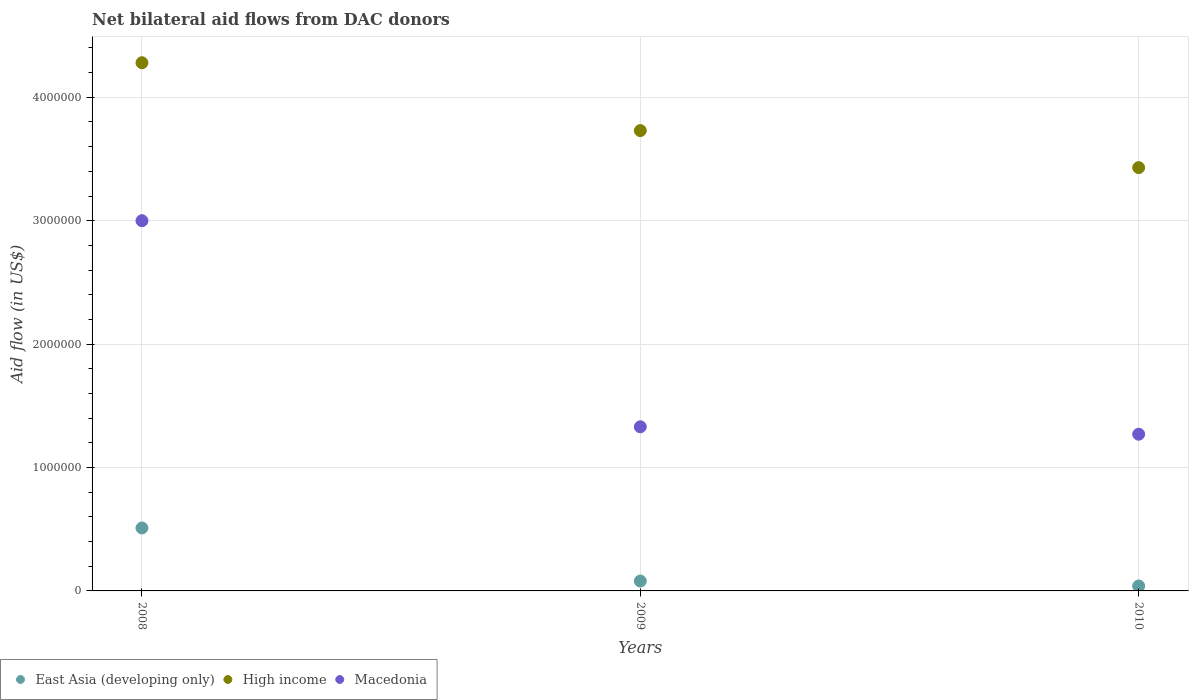How many different coloured dotlines are there?
Keep it short and to the point. 3. What is the net bilateral aid flow in Macedonia in 2009?
Provide a short and direct response. 1.33e+06. Across all years, what is the maximum net bilateral aid flow in High income?
Your answer should be compact. 4.28e+06. Across all years, what is the minimum net bilateral aid flow in High income?
Your answer should be very brief. 3.43e+06. In which year was the net bilateral aid flow in East Asia (developing only) maximum?
Your answer should be very brief. 2008. What is the total net bilateral aid flow in East Asia (developing only) in the graph?
Ensure brevity in your answer.  6.30e+05. What is the difference between the net bilateral aid flow in East Asia (developing only) in 2008 and that in 2010?
Give a very brief answer. 4.70e+05. What is the difference between the net bilateral aid flow in High income in 2010 and the net bilateral aid flow in East Asia (developing only) in 2008?
Ensure brevity in your answer.  2.92e+06. What is the average net bilateral aid flow in High income per year?
Provide a short and direct response. 3.81e+06. In the year 2008, what is the difference between the net bilateral aid flow in High income and net bilateral aid flow in Macedonia?
Provide a short and direct response. 1.28e+06. What is the ratio of the net bilateral aid flow in Macedonia in 2008 to that in 2010?
Keep it short and to the point. 2.36. Is the difference between the net bilateral aid flow in High income in 2008 and 2009 greater than the difference between the net bilateral aid flow in Macedonia in 2008 and 2009?
Ensure brevity in your answer.  No. What is the difference between the highest and the lowest net bilateral aid flow in High income?
Offer a terse response. 8.50e+05. In how many years, is the net bilateral aid flow in Macedonia greater than the average net bilateral aid flow in Macedonia taken over all years?
Provide a succinct answer. 1. Is the sum of the net bilateral aid flow in High income in 2009 and 2010 greater than the maximum net bilateral aid flow in Macedonia across all years?
Ensure brevity in your answer.  Yes. Is it the case that in every year, the sum of the net bilateral aid flow in East Asia (developing only) and net bilateral aid flow in High income  is greater than the net bilateral aid flow in Macedonia?
Give a very brief answer. Yes. Does the net bilateral aid flow in High income monotonically increase over the years?
Offer a terse response. No. Is the net bilateral aid flow in Macedonia strictly greater than the net bilateral aid flow in High income over the years?
Keep it short and to the point. No. Are the values on the major ticks of Y-axis written in scientific E-notation?
Make the answer very short. No. How many legend labels are there?
Provide a succinct answer. 3. How are the legend labels stacked?
Keep it short and to the point. Horizontal. What is the title of the graph?
Your response must be concise. Net bilateral aid flows from DAC donors. Does "South Sudan" appear as one of the legend labels in the graph?
Offer a terse response. No. What is the label or title of the Y-axis?
Ensure brevity in your answer.  Aid flow (in US$). What is the Aid flow (in US$) of East Asia (developing only) in 2008?
Provide a short and direct response. 5.10e+05. What is the Aid flow (in US$) in High income in 2008?
Make the answer very short. 4.28e+06. What is the Aid flow (in US$) in Macedonia in 2008?
Give a very brief answer. 3.00e+06. What is the Aid flow (in US$) in High income in 2009?
Ensure brevity in your answer.  3.73e+06. What is the Aid flow (in US$) in Macedonia in 2009?
Offer a very short reply. 1.33e+06. What is the Aid flow (in US$) in High income in 2010?
Offer a terse response. 3.43e+06. What is the Aid flow (in US$) in Macedonia in 2010?
Offer a terse response. 1.27e+06. Across all years, what is the maximum Aid flow (in US$) in East Asia (developing only)?
Offer a terse response. 5.10e+05. Across all years, what is the maximum Aid flow (in US$) in High income?
Your answer should be very brief. 4.28e+06. Across all years, what is the maximum Aid flow (in US$) of Macedonia?
Your answer should be very brief. 3.00e+06. Across all years, what is the minimum Aid flow (in US$) of East Asia (developing only)?
Your answer should be compact. 4.00e+04. Across all years, what is the minimum Aid flow (in US$) of High income?
Offer a very short reply. 3.43e+06. Across all years, what is the minimum Aid flow (in US$) of Macedonia?
Your answer should be very brief. 1.27e+06. What is the total Aid flow (in US$) of East Asia (developing only) in the graph?
Offer a very short reply. 6.30e+05. What is the total Aid flow (in US$) of High income in the graph?
Ensure brevity in your answer.  1.14e+07. What is the total Aid flow (in US$) in Macedonia in the graph?
Your answer should be compact. 5.60e+06. What is the difference between the Aid flow (in US$) in High income in 2008 and that in 2009?
Make the answer very short. 5.50e+05. What is the difference between the Aid flow (in US$) in Macedonia in 2008 and that in 2009?
Provide a succinct answer. 1.67e+06. What is the difference between the Aid flow (in US$) in High income in 2008 and that in 2010?
Give a very brief answer. 8.50e+05. What is the difference between the Aid flow (in US$) of Macedonia in 2008 and that in 2010?
Make the answer very short. 1.73e+06. What is the difference between the Aid flow (in US$) in East Asia (developing only) in 2008 and the Aid flow (in US$) in High income in 2009?
Ensure brevity in your answer.  -3.22e+06. What is the difference between the Aid flow (in US$) of East Asia (developing only) in 2008 and the Aid flow (in US$) of Macedonia in 2009?
Provide a succinct answer. -8.20e+05. What is the difference between the Aid flow (in US$) of High income in 2008 and the Aid flow (in US$) of Macedonia in 2009?
Make the answer very short. 2.95e+06. What is the difference between the Aid flow (in US$) in East Asia (developing only) in 2008 and the Aid flow (in US$) in High income in 2010?
Provide a succinct answer. -2.92e+06. What is the difference between the Aid flow (in US$) of East Asia (developing only) in 2008 and the Aid flow (in US$) of Macedonia in 2010?
Make the answer very short. -7.60e+05. What is the difference between the Aid flow (in US$) of High income in 2008 and the Aid flow (in US$) of Macedonia in 2010?
Your response must be concise. 3.01e+06. What is the difference between the Aid flow (in US$) in East Asia (developing only) in 2009 and the Aid flow (in US$) in High income in 2010?
Provide a short and direct response. -3.35e+06. What is the difference between the Aid flow (in US$) in East Asia (developing only) in 2009 and the Aid flow (in US$) in Macedonia in 2010?
Offer a terse response. -1.19e+06. What is the difference between the Aid flow (in US$) in High income in 2009 and the Aid flow (in US$) in Macedonia in 2010?
Your answer should be very brief. 2.46e+06. What is the average Aid flow (in US$) in East Asia (developing only) per year?
Make the answer very short. 2.10e+05. What is the average Aid flow (in US$) in High income per year?
Your answer should be very brief. 3.81e+06. What is the average Aid flow (in US$) in Macedonia per year?
Provide a short and direct response. 1.87e+06. In the year 2008, what is the difference between the Aid flow (in US$) in East Asia (developing only) and Aid flow (in US$) in High income?
Your response must be concise. -3.77e+06. In the year 2008, what is the difference between the Aid flow (in US$) in East Asia (developing only) and Aid flow (in US$) in Macedonia?
Offer a very short reply. -2.49e+06. In the year 2008, what is the difference between the Aid flow (in US$) in High income and Aid flow (in US$) in Macedonia?
Provide a short and direct response. 1.28e+06. In the year 2009, what is the difference between the Aid flow (in US$) of East Asia (developing only) and Aid flow (in US$) of High income?
Your answer should be very brief. -3.65e+06. In the year 2009, what is the difference between the Aid flow (in US$) of East Asia (developing only) and Aid flow (in US$) of Macedonia?
Provide a succinct answer. -1.25e+06. In the year 2009, what is the difference between the Aid flow (in US$) of High income and Aid flow (in US$) of Macedonia?
Give a very brief answer. 2.40e+06. In the year 2010, what is the difference between the Aid flow (in US$) in East Asia (developing only) and Aid flow (in US$) in High income?
Your answer should be compact. -3.39e+06. In the year 2010, what is the difference between the Aid flow (in US$) in East Asia (developing only) and Aid flow (in US$) in Macedonia?
Offer a very short reply. -1.23e+06. In the year 2010, what is the difference between the Aid flow (in US$) in High income and Aid flow (in US$) in Macedonia?
Keep it short and to the point. 2.16e+06. What is the ratio of the Aid flow (in US$) in East Asia (developing only) in 2008 to that in 2009?
Offer a terse response. 6.38. What is the ratio of the Aid flow (in US$) of High income in 2008 to that in 2009?
Keep it short and to the point. 1.15. What is the ratio of the Aid flow (in US$) in Macedonia in 2008 to that in 2009?
Ensure brevity in your answer.  2.26. What is the ratio of the Aid flow (in US$) in East Asia (developing only) in 2008 to that in 2010?
Offer a terse response. 12.75. What is the ratio of the Aid flow (in US$) of High income in 2008 to that in 2010?
Make the answer very short. 1.25. What is the ratio of the Aid flow (in US$) of Macedonia in 2008 to that in 2010?
Your response must be concise. 2.36. What is the ratio of the Aid flow (in US$) in East Asia (developing only) in 2009 to that in 2010?
Your answer should be very brief. 2. What is the ratio of the Aid flow (in US$) of High income in 2009 to that in 2010?
Ensure brevity in your answer.  1.09. What is the ratio of the Aid flow (in US$) in Macedonia in 2009 to that in 2010?
Your answer should be compact. 1.05. What is the difference between the highest and the second highest Aid flow (in US$) in East Asia (developing only)?
Offer a terse response. 4.30e+05. What is the difference between the highest and the second highest Aid flow (in US$) in High income?
Make the answer very short. 5.50e+05. What is the difference between the highest and the second highest Aid flow (in US$) in Macedonia?
Your answer should be compact. 1.67e+06. What is the difference between the highest and the lowest Aid flow (in US$) in High income?
Ensure brevity in your answer.  8.50e+05. What is the difference between the highest and the lowest Aid flow (in US$) in Macedonia?
Your answer should be compact. 1.73e+06. 